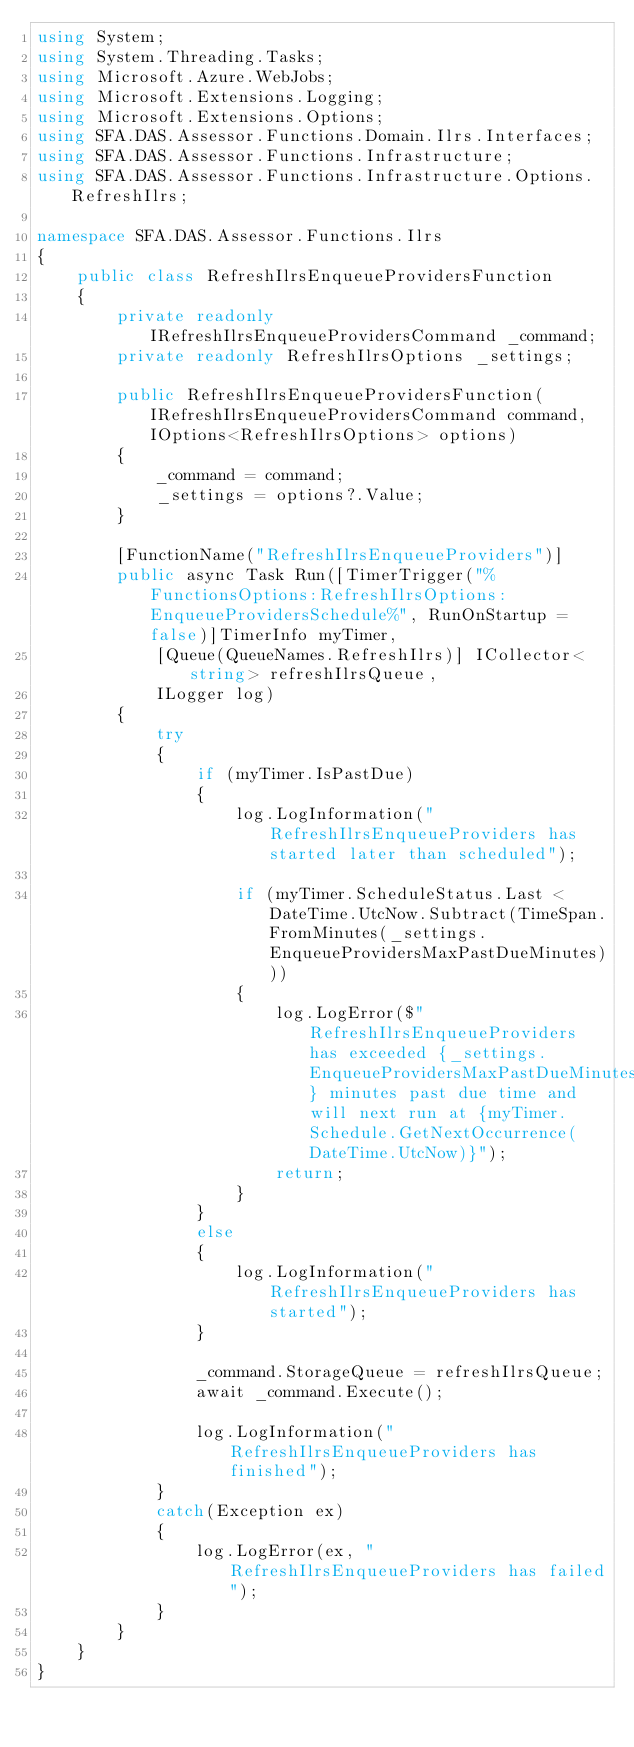<code> <loc_0><loc_0><loc_500><loc_500><_C#_>using System;
using System.Threading.Tasks;
using Microsoft.Azure.WebJobs;
using Microsoft.Extensions.Logging;
using Microsoft.Extensions.Options;
using SFA.DAS.Assessor.Functions.Domain.Ilrs.Interfaces;
using SFA.DAS.Assessor.Functions.Infrastructure;
using SFA.DAS.Assessor.Functions.Infrastructure.Options.RefreshIlrs;

namespace SFA.DAS.Assessor.Functions.Ilrs
{
    public class RefreshIlrsEnqueueProvidersFunction
    {
        private readonly IRefreshIlrsEnqueueProvidersCommand _command;
        private readonly RefreshIlrsOptions _settings;

        public RefreshIlrsEnqueueProvidersFunction(IRefreshIlrsEnqueueProvidersCommand command, IOptions<RefreshIlrsOptions> options)
        {
            _command = command;
            _settings = options?.Value;
        }

        [FunctionName("RefreshIlrsEnqueueProviders")]
        public async Task Run([TimerTrigger("%FunctionsOptions:RefreshIlrsOptions:EnqueueProvidersSchedule%", RunOnStartup = false)]TimerInfo myTimer,
            [Queue(QueueNames.RefreshIlrs)] ICollector<string> refreshIlrsQueue,
            ILogger log)
        {
            try
            {
                if (myTimer.IsPastDue)
                {
                    log.LogInformation("RefreshIlrsEnqueueProviders has started later than scheduled");

                    if (myTimer.ScheduleStatus.Last < DateTime.UtcNow.Subtract(TimeSpan.FromMinutes(_settings.EnqueueProvidersMaxPastDueMinutes)))
                    {
                        log.LogError($"RefreshIlrsEnqueueProviders has exceeded {_settings.EnqueueProvidersMaxPastDueMinutes} minutes past due time and will next run at {myTimer.Schedule.GetNextOccurrence(DateTime.UtcNow)}");
                        return;
                    }
                }
                else
                {
                    log.LogInformation("RefreshIlrsEnqueueProviders has started");
                }

                _command.StorageQueue = refreshIlrsQueue;
                await _command.Execute();

                log.LogInformation("RefreshIlrsEnqueueProviders has finished");
            }
            catch(Exception ex)
            {
                log.LogError(ex, "RefreshIlrsEnqueueProviders has failed");
            }
        }
    }
}
</code> 